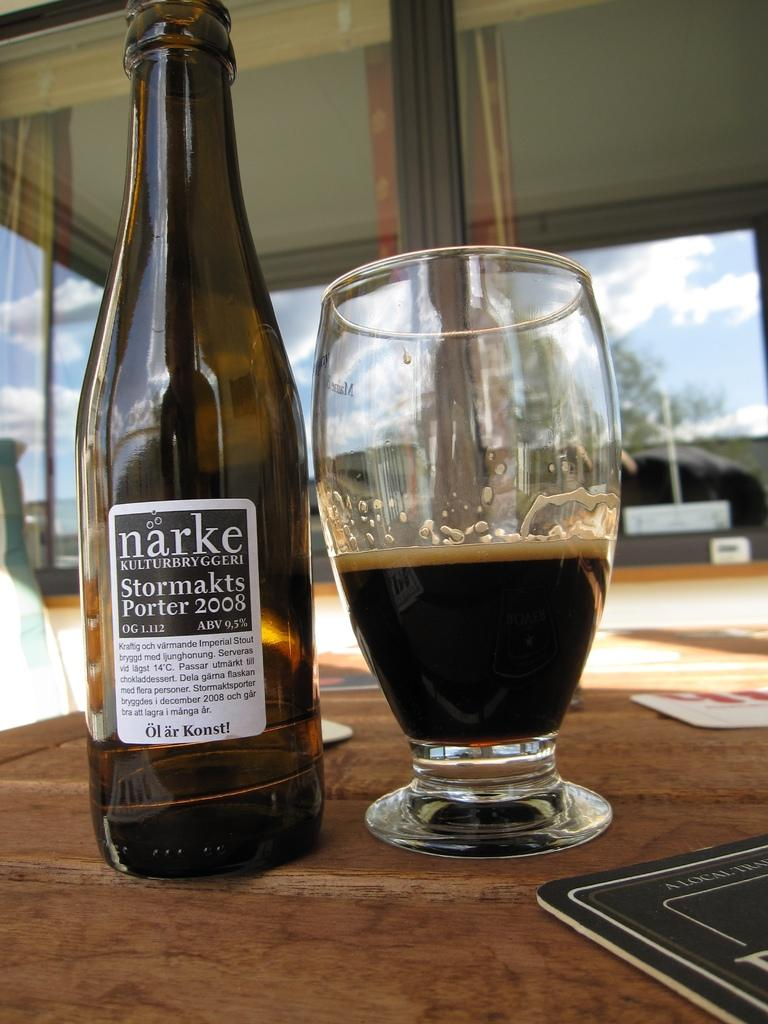Provide a one-sentence caption for the provided image. A bottle of narke booze next to a glass half full of booze. 